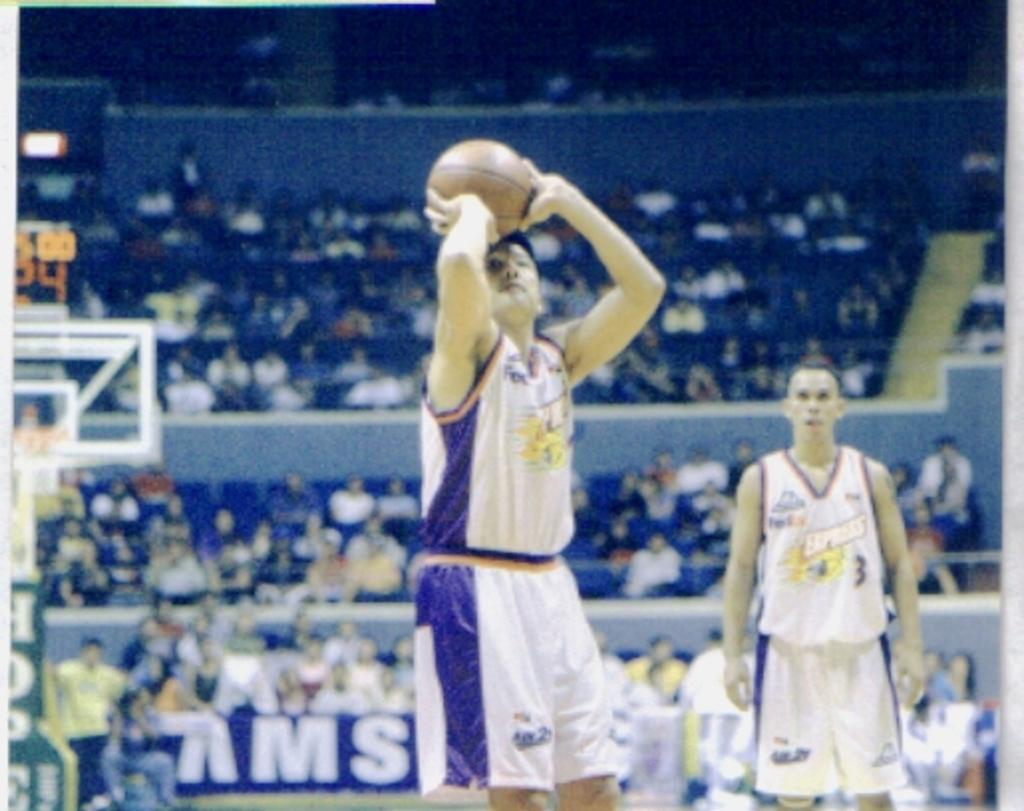Can you describe this image briefly? In this image there are people playing with ball, at the back there are so many people sitting in the stadium and watching at the game. 